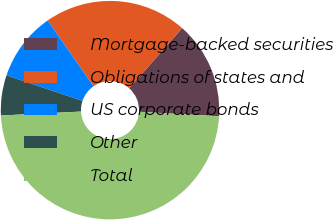Convert chart to OTSL. <chart><loc_0><loc_0><loc_500><loc_500><pie_chart><fcel>Mortgage-backed securities<fcel>Obligations of states and<fcel>US corporate bonds<fcel>Other<fcel>Total<nl><fcel>14.42%<fcel>21.14%<fcel>10.18%<fcel>5.94%<fcel>48.33%<nl></chart> 